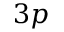<formula> <loc_0><loc_0><loc_500><loc_500>3 p</formula> 